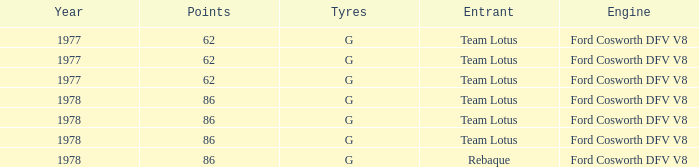What is the Focus that has a Year bigger than 1977? 86, 86, 86, 86. 